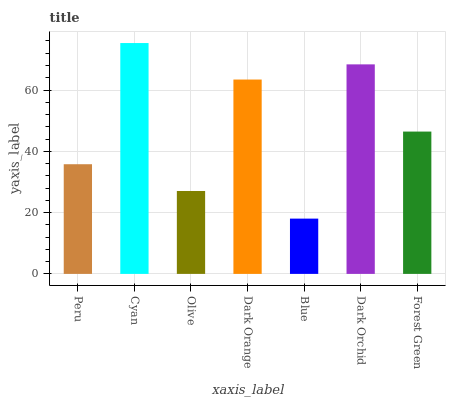Is Blue the minimum?
Answer yes or no. Yes. Is Cyan the maximum?
Answer yes or no. Yes. Is Olive the minimum?
Answer yes or no. No. Is Olive the maximum?
Answer yes or no. No. Is Cyan greater than Olive?
Answer yes or no. Yes. Is Olive less than Cyan?
Answer yes or no. Yes. Is Olive greater than Cyan?
Answer yes or no. No. Is Cyan less than Olive?
Answer yes or no. No. Is Forest Green the high median?
Answer yes or no. Yes. Is Forest Green the low median?
Answer yes or no. Yes. Is Cyan the high median?
Answer yes or no. No. Is Cyan the low median?
Answer yes or no. No. 